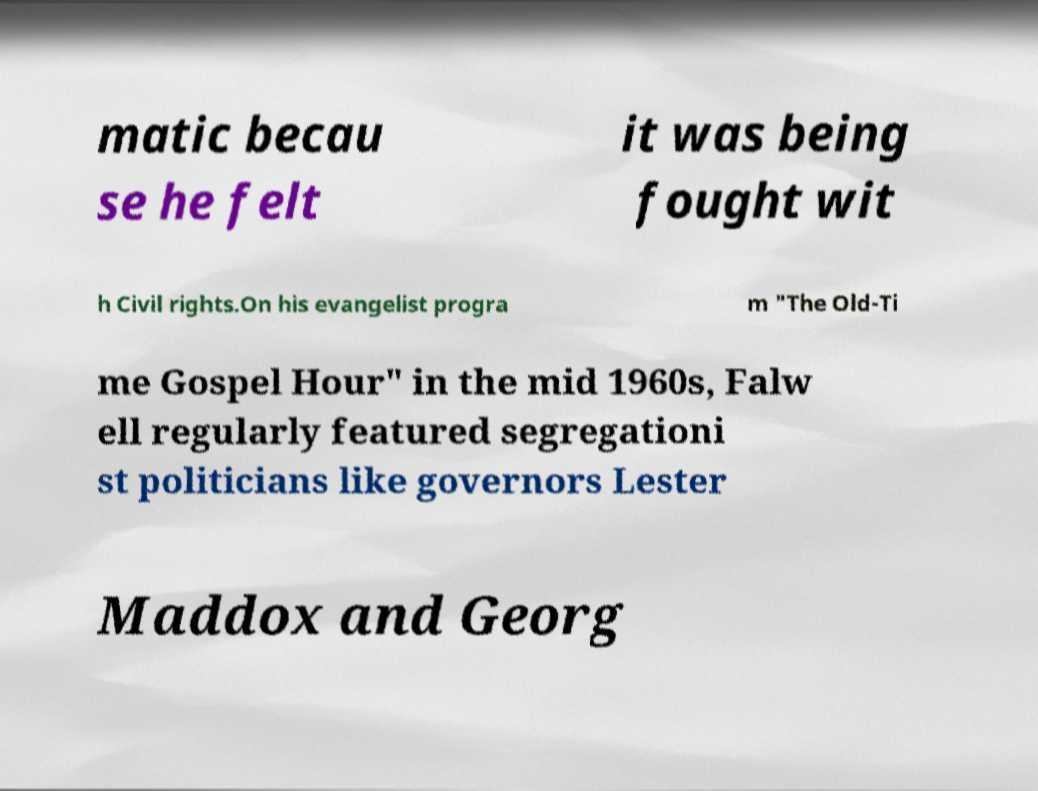I need the written content from this picture converted into text. Can you do that? matic becau se he felt it was being fought wit h Civil rights.On his evangelist progra m "The Old-Ti me Gospel Hour" in the mid 1960s, Falw ell regularly featured segregationi st politicians like governors Lester Maddox and Georg 